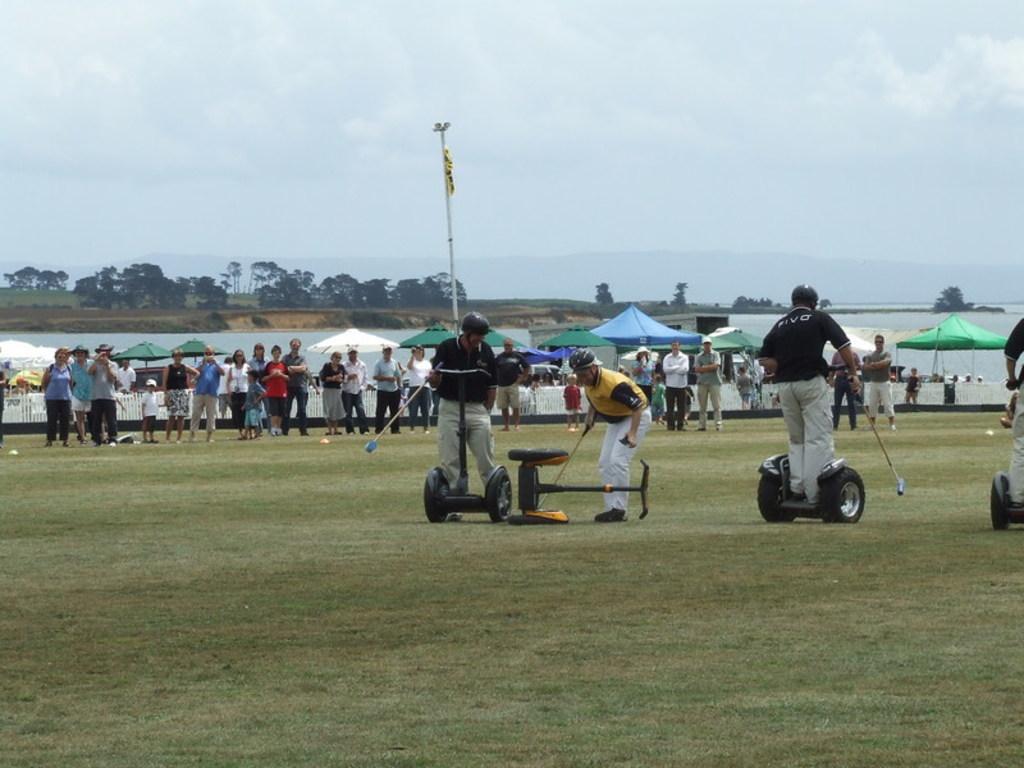Can you describe this image briefly? In this image, we can see a group of people. Few are playing a game with segways on the ground. They are holding sticks. Here there is a pole. Background we can see trees, water, umbrellas, railing and sky. 